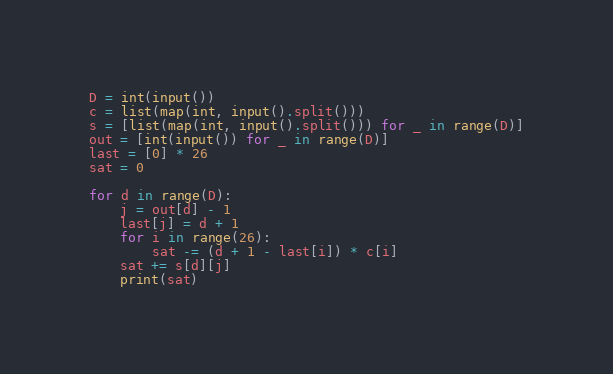<code> <loc_0><loc_0><loc_500><loc_500><_Python_>D = int(input())
c = list(map(int, input().split()))
s = [list(map(int, input().split())) for _ in range(D)]
out = [int(input()) for _ in range(D)]
last = [0] * 26
sat = 0

for d in range(D):
    j = out[d] - 1
    last[j] = d + 1
    for i in range(26):
        sat -= (d + 1 - last[i]) * c[i]
    sat += s[d][j]
    print(sat)
</code> 